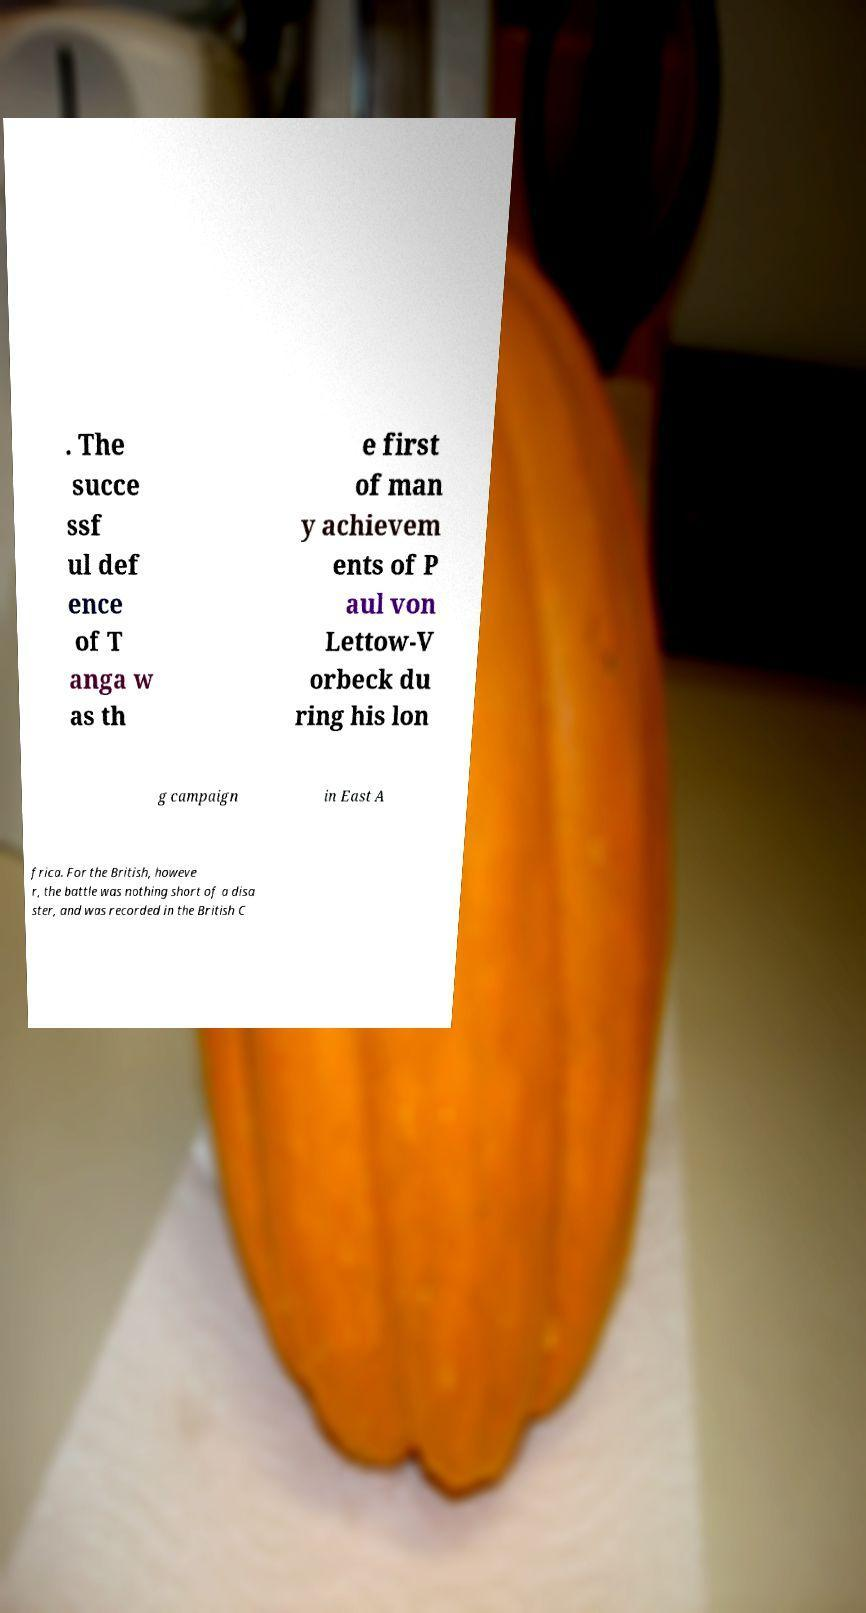Please identify and transcribe the text found in this image. . The succe ssf ul def ence of T anga w as th e first of man y achievem ents of P aul von Lettow-V orbeck du ring his lon g campaign in East A frica. For the British, howeve r, the battle was nothing short of a disa ster, and was recorded in the British C 